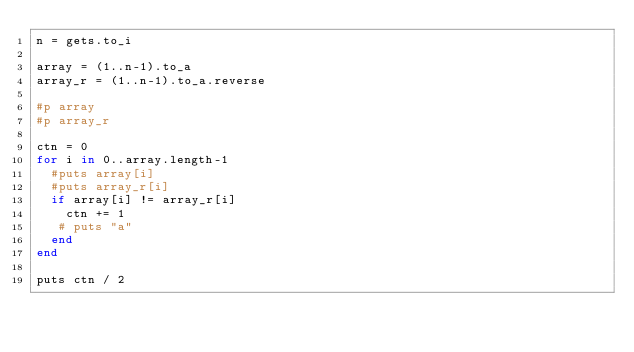Convert code to text. <code><loc_0><loc_0><loc_500><loc_500><_Ruby_>n = gets.to_i

array = (1..n-1).to_a
array_r = (1..n-1).to_a.reverse

#p array
#p array_r

ctn = 0
for i in 0..array.length-1
  #puts array[i]
  #puts array_r[i]
  if array[i] != array_r[i]
    ctn += 1
   # puts "a"
  end
end

puts ctn / 2</code> 